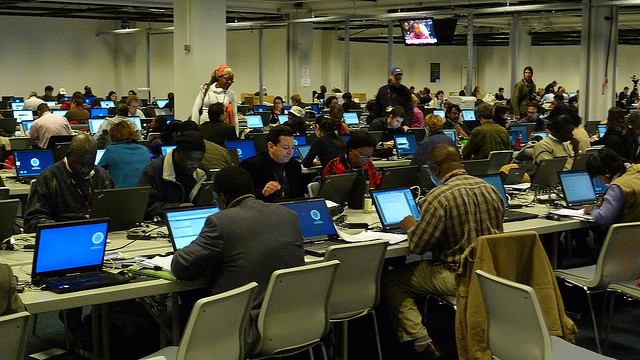Are there any distinguishing features in the room that provide more context? Unique features include a projection screen, which implies the presence of presentations or lectures, and uniform rows of tables with laptops, indicating a structured setup typically found in educational or professional gatherings. 